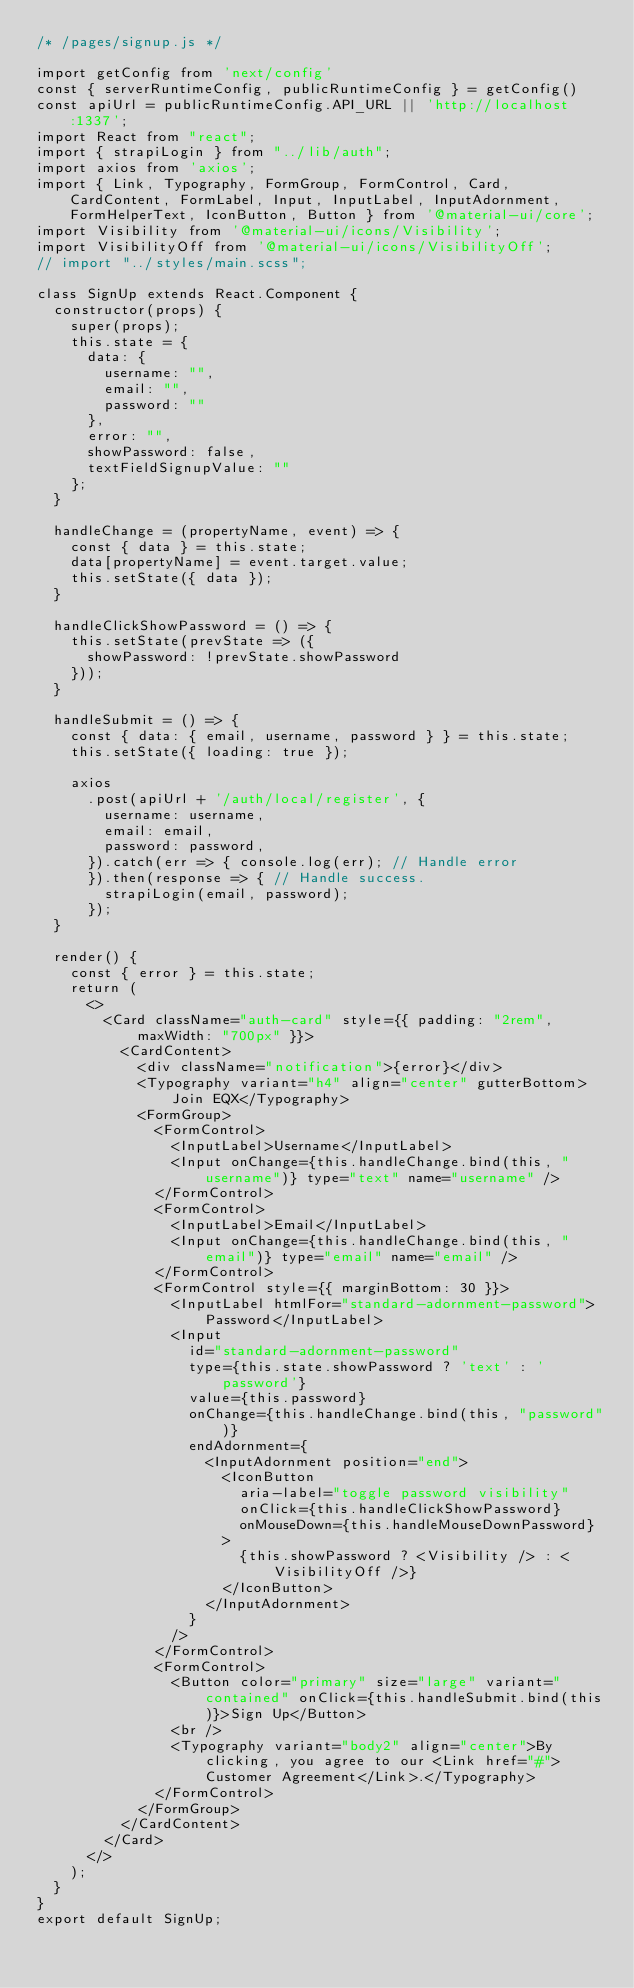Convert code to text. <code><loc_0><loc_0><loc_500><loc_500><_JavaScript_>/* /pages/signup.js */

import getConfig from 'next/config'
const { serverRuntimeConfig, publicRuntimeConfig } = getConfig()
const apiUrl = publicRuntimeConfig.API_URL || 'http://localhost:1337';
import React from "react";
import { strapiLogin } from "../lib/auth";
import axios from 'axios';
import { Link, Typography, FormGroup, FormControl, Card, CardContent, FormLabel, Input, InputLabel, InputAdornment, FormHelperText, IconButton, Button } from '@material-ui/core';
import Visibility from '@material-ui/icons/Visibility';
import VisibilityOff from '@material-ui/icons/VisibilityOff';
// import "../styles/main.scss";

class SignUp extends React.Component {
  constructor(props) {
    super(props);
    this.state = {
      data: {
        username: "",
        email: "",
        password: ""
      },
      error: "",
      showPassword: false,
      textFieldSignupValue: ""
    };
  }

  handleChange = (propertyName, event) => {
    const { data } = this.state;
    data[propertyName] = event.target.value;
    this.setState({ data });
  }

  handleClickShowPassword = () => {
    this.setState(prevState => ({
      showPassword: !prevState.showPassword
    }));
  }

  handleSubmit = () => {
    const { data: { email, username, password } } = this.state;
    this.setState({ loading: true });

    axios
      .post(apiUrl + '/auth/local/register', {
        username: username,
        email: email,
        password: password,
      }).catch(err => { console.log(err); // Handle error
      }).then(response => { // Handle success.
        strapiLogin(email, password);
      });
  }

  render() {
    const { error } = this.state;
    return (
      <>
        <Card className="auth-card" style={{ padding: "2rem", maxWidth: "700px" }}>
          <CardContent>
            <div className="notification">{error}</div>
            <Typography variant="h4" align="center" gutterBottom>Join EQX</Typography>
            <FormGroup>
              <FormControl>
                <InputLabel>Username</InputLabel>
                <Input onChange={this.handleChange.bind(this, "username")} type="text" name="username" />
              </FormControl>
              <FormControl>
                <InputLabel>Email</InputLabel>
                <Input onChange={this.handleChange.bind(this, "email")} type="email" name="email" />
              </FormControl>
              <FormControl style={{ marginBottom: 30 }}>
                <InputLabel htmlFor="standard-adornment-password">Password</InputLabel>
                <Input
                  id="standard-adornment-password"
                  type={this.state.showPassword ? 'text' : 'password'}
                  value={this.password}
                  onChange={this.handleChange.bind(this, "password")}
                  endAdornment={
                    <InputAdornment position="end">
                      <IconButton
                        aria-label="toggle password visibility"
                        onClick={this.handleClickShowPassword}
                        onMouseDown={this.handleMouseDownPassword}
                      >
                        {this.showPassword ? <Visibility /> : <VisibilityOff />}
                      </IconButton>
                    </InputAdornment>
                  }
                />
              </FormControl>
              <FormControl>
                <Button color="primary" size="large" variant="contained" onClick={this.handleSubmit.bind(this)}>Sign Up</Button>
                <br />
                <Typography variant="body2" align="center">By clicking, you agree to our <Link href="#">Customer Agreement</Link>.</Typography>
              </FormControl>
            </FormGroup>
          </CardContent>
        </Card>
      </>
    );
  }
}
export default SignUp;</code> 